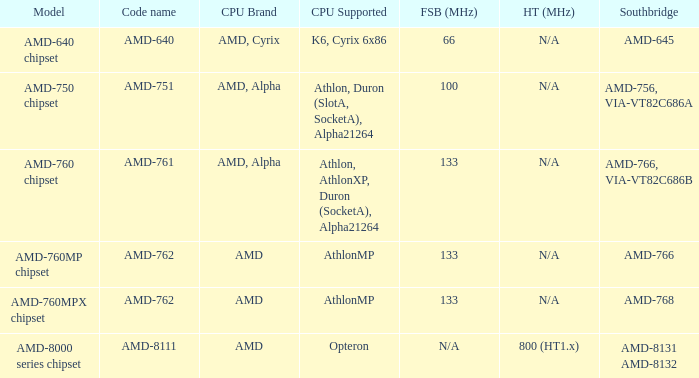What shows for Southbridge when the Model number is amd-640 chipset? AMD-645. 